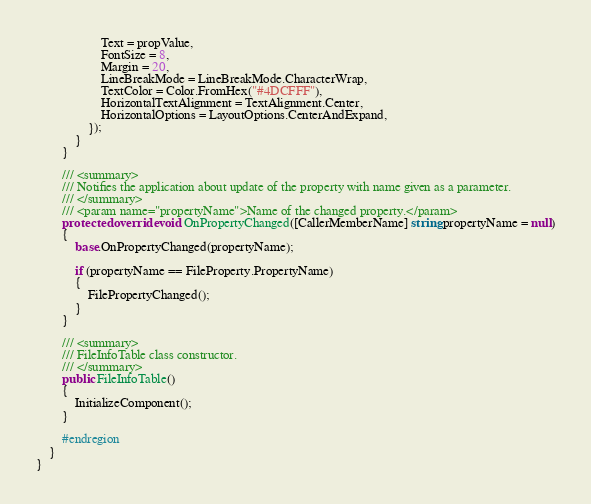Convert code to text. <code><loc_0><loc_0><loc_500><loc_500><_C#_>                    Text = propValue,
                    FontSize = 8,
                    Margin = 20,
                    LineBreakMode = LineBreakMode.CharacterWrap,
                    TextColor = Color.FromHex("#4DCFFF"),
                    HorizontalTextAlignment = TextAlignment.Center,
                    HorizontalOptions = LayoutOptions.CenterAndExpand,
                });
            }
        }

        /// <summary>
        /// Notifies the application about update of the property with name given as a parameter.
        /// </summary>
        /// <param name="propertyName">Name of the changed property.</param>
        protected override void OnPropertyChanged([CallerMemberName] string propertyName = null)
        {
            base.OnPropertyChanged(propertyName);

            if (propertyName == FileProperty.PropertyName)
            {
                FilePropertyChanged();
            }
        }

        /// <summary>
        /// FileInfoTable class constructor.
        /// </summary>
        public FileInfoTable()
        {
            InitializeComponent();
        }

        #endregion
    }
}</code> 